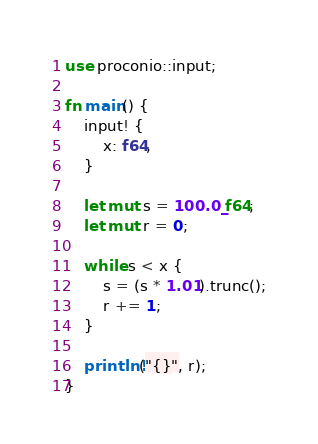Convert code to text. <code><loc_0><loc_0><loc_500><loc_500><_Rust_>use proconio::input;

fn main() {
    input! {
        x: f64,
    }

    let mut s = 100.0_f64;
    let mut r = 0;

    while s < x {
        s = (s * 1.01).trunc();
        r += 1;
    }

    println!("{}", r);
}
</code> 